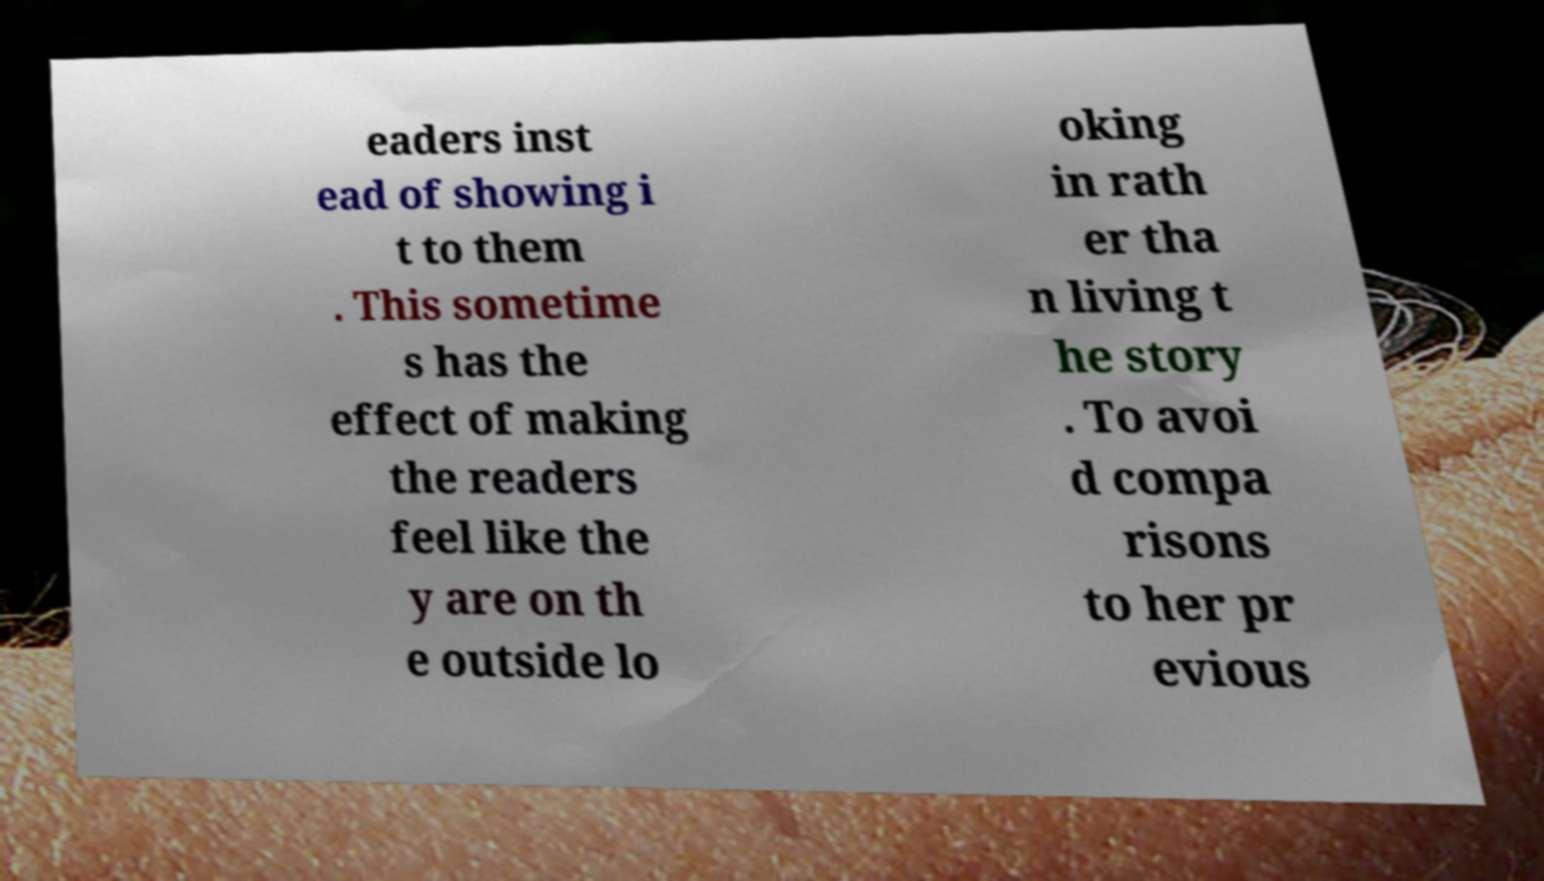There's text embedded in this image that I need extracted. Can you transcribe it verbatim? eaders inst ead of showing i t to them . This sometime s has the effect of making the readers feel like the y are on th e outside lo oking in rath er tha n living t he story . To avoi d compa risons to her pr evious 